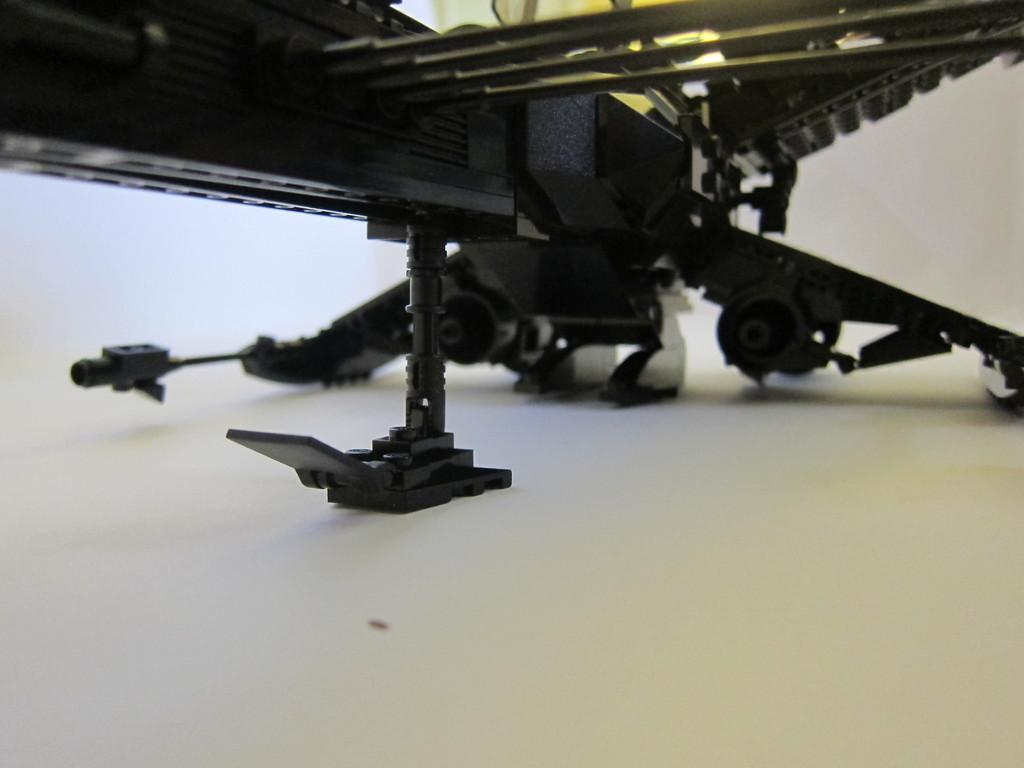What type of war craft is visible in the image? There is a part of a war craft visible in the image. Can you describe the location of the war craft in the image? The war craft is on the surface in the image. Where is the sink located in the image? There is no sink present in the image. What type of harbor can be seen in the image? There is no harbor present in the image. 